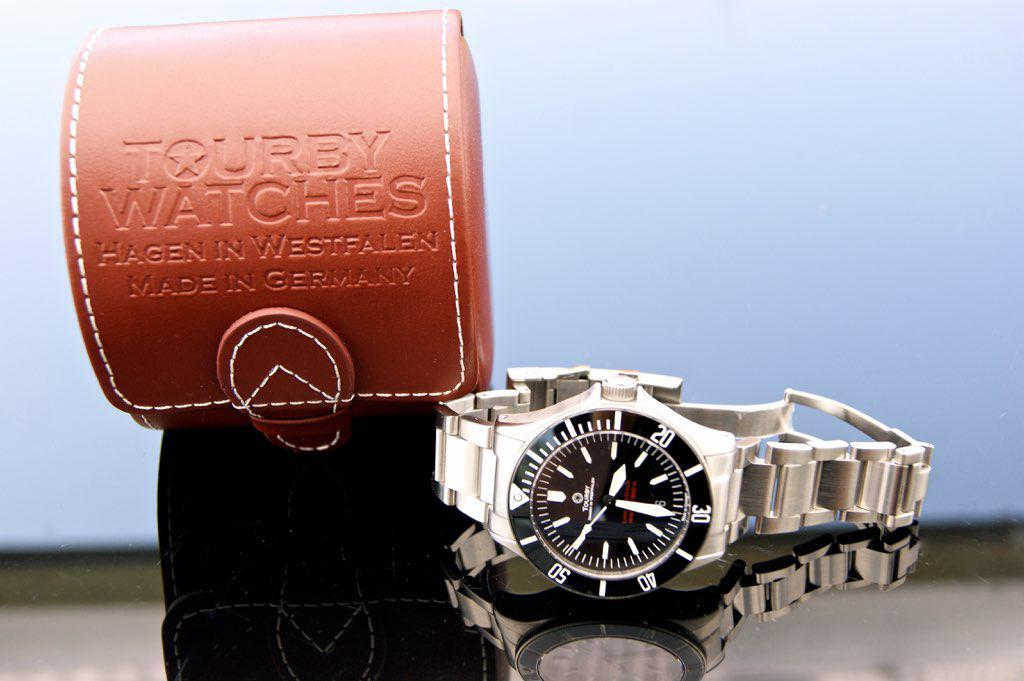<image>
Render a clear and concise summary of the photo. A Tourby watch and leather case are side by side. 